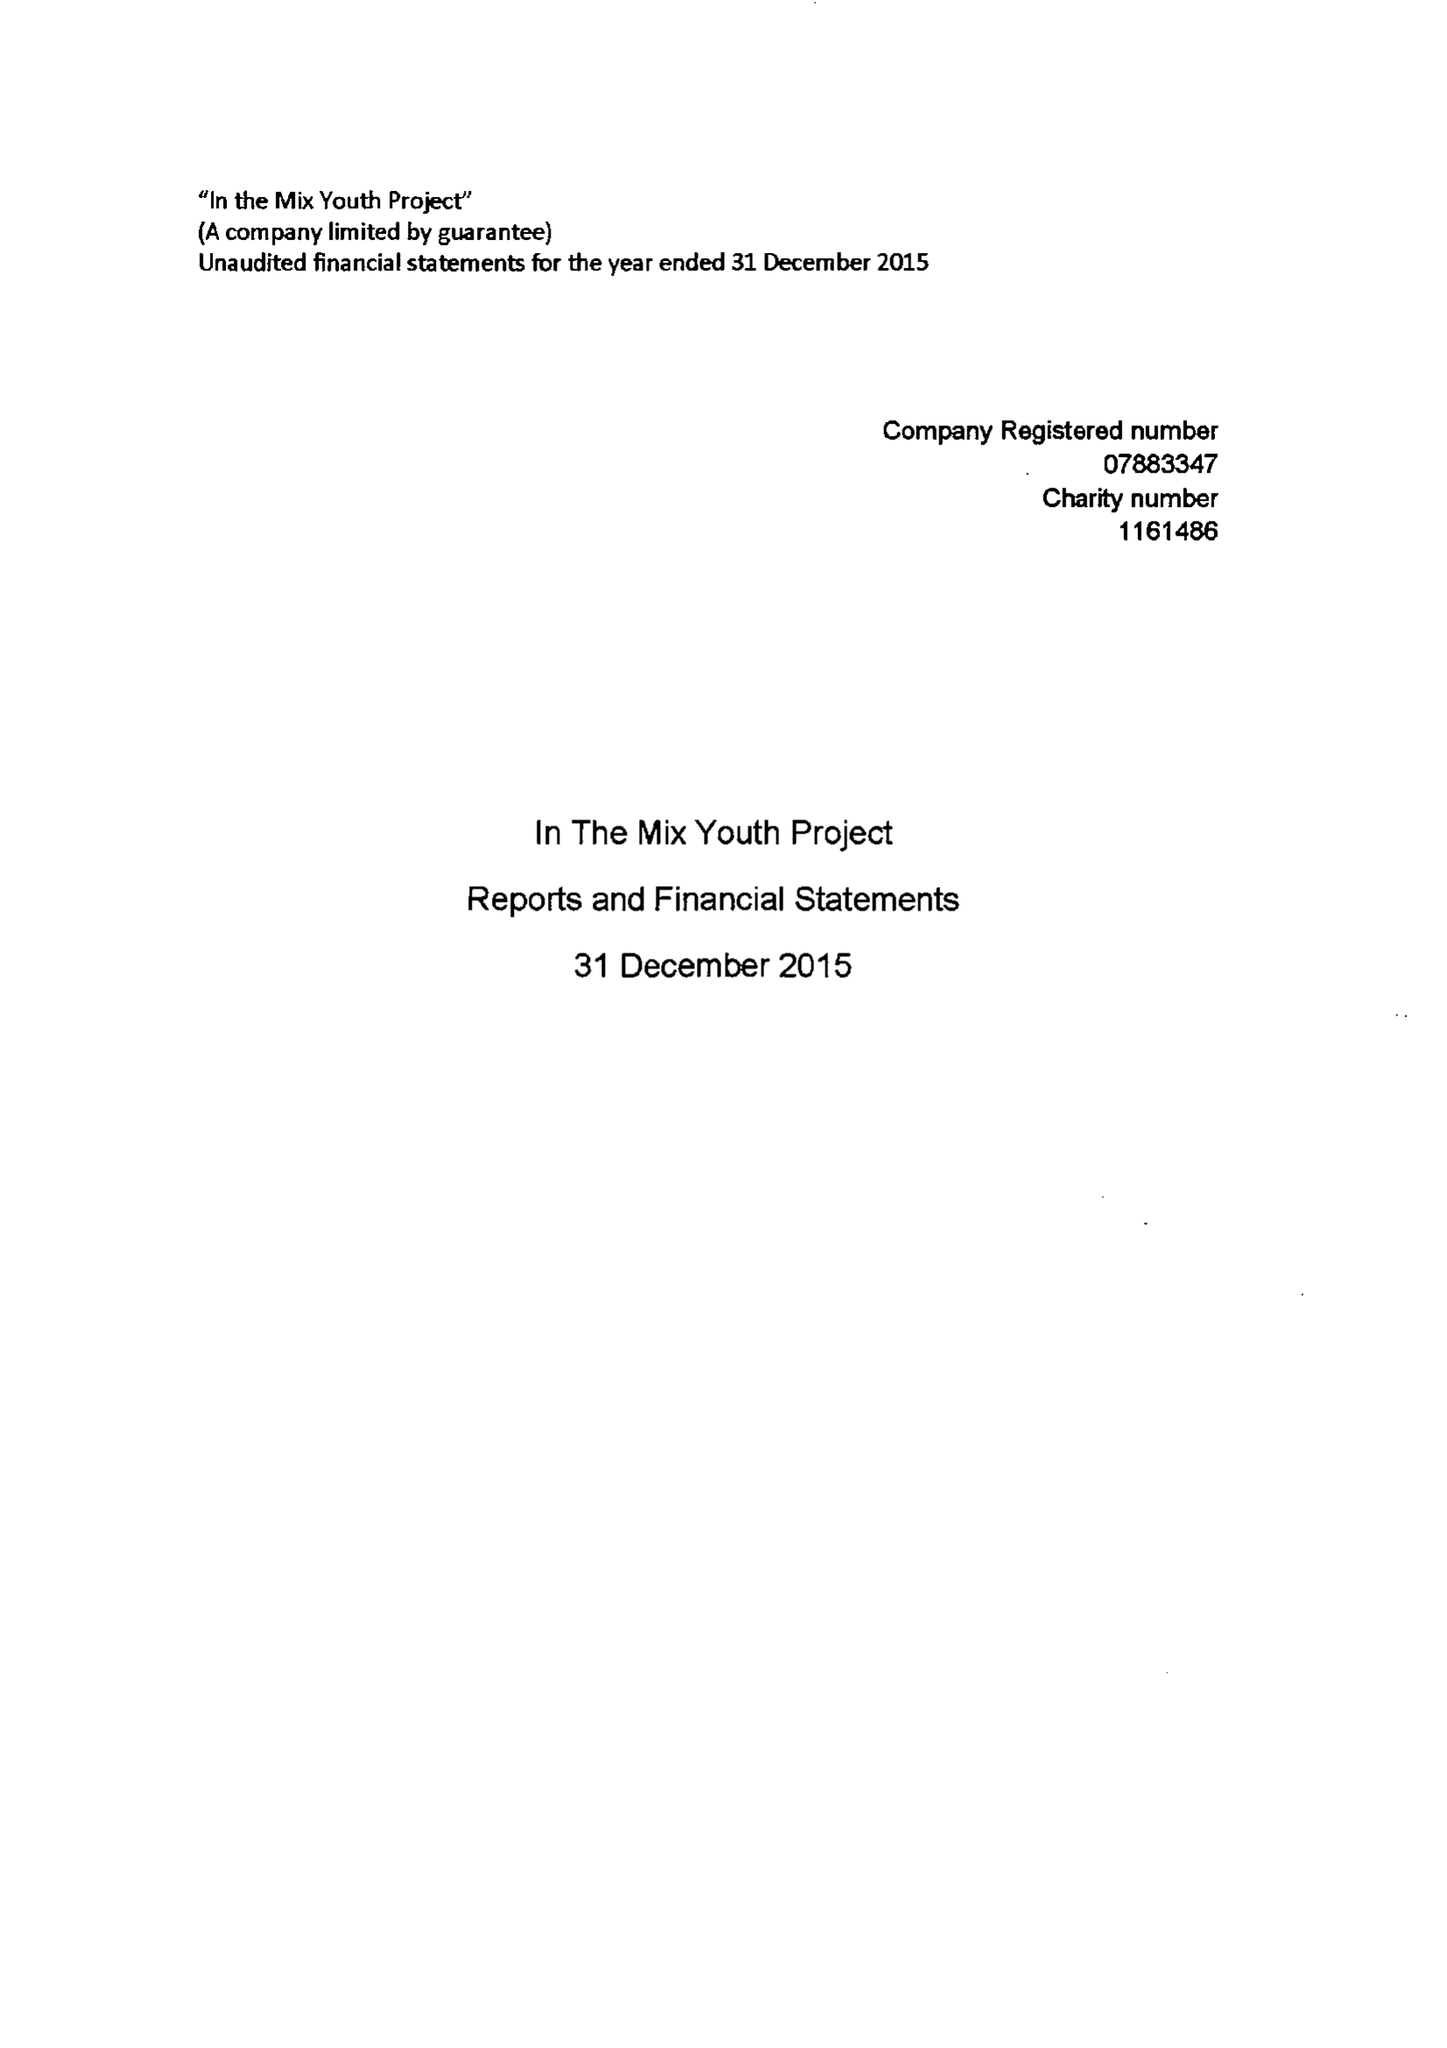What is the value for the address__street_line?
Answer the question using a single word or phrase. HARTSWELL 